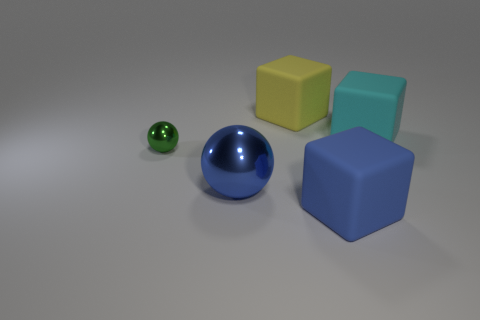Can you describe the arrangement of the objects in terms of their proximity to each other? Certainly. The objects are arranged in a scattered formation. The tiny green metallic ball is the closest to the foreground, followed by the large blue rubber ball slightly behind it. The yellow and cyan cubes are positioned next to each other on one side, while the larger blue cube is set apart on the opposite side, creating a triangular formation around the blue ball. 